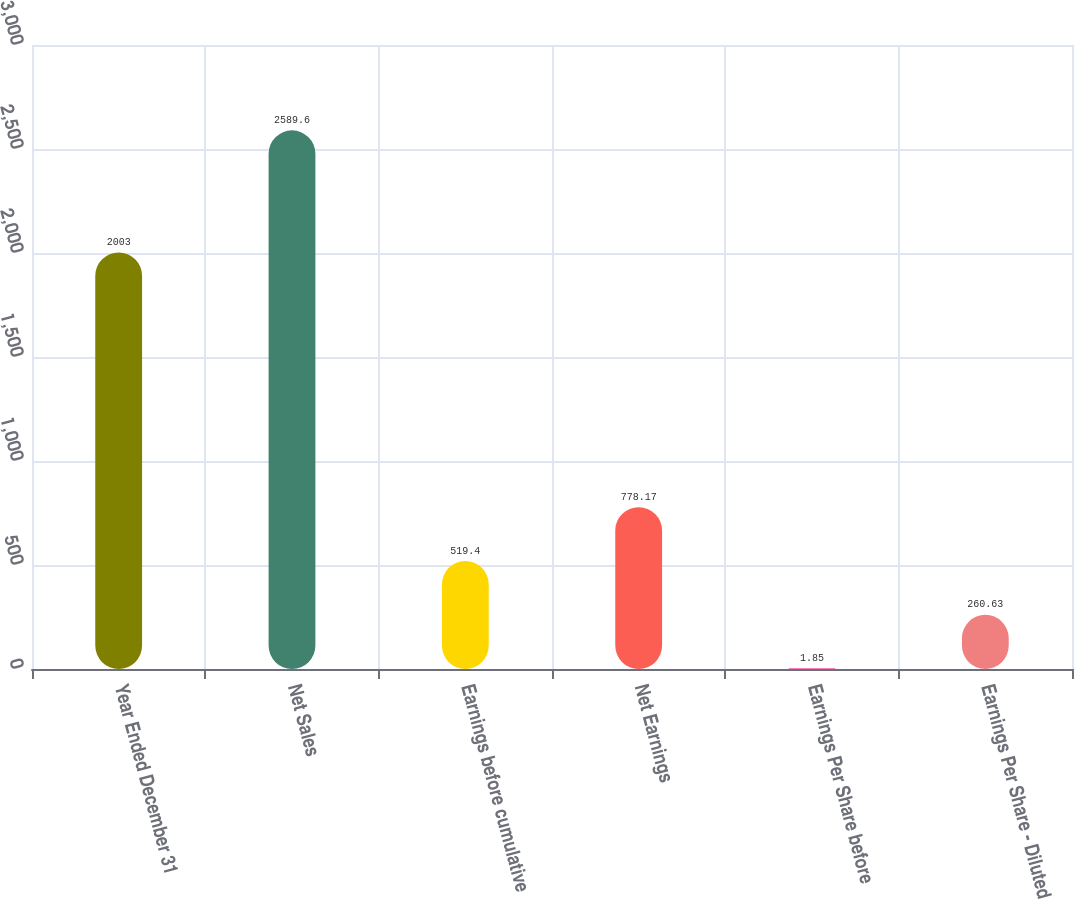Convert chart. <chart><loc_0><loc_0><loc_500><loc_500><bar_chart><fcel>Year Ended December 31<fcel>Net Sales<fcel>Earnings before cumulative<fcel>Net Earnings<fcel>Earnings Per Share before<fcel>Earnings Per Share - Diluted<nl><fcel>2003<fcel>2589.6<fcel>519.4<fcel>778.17<fcel>1.85<fcel>260.63<nl></chart> 